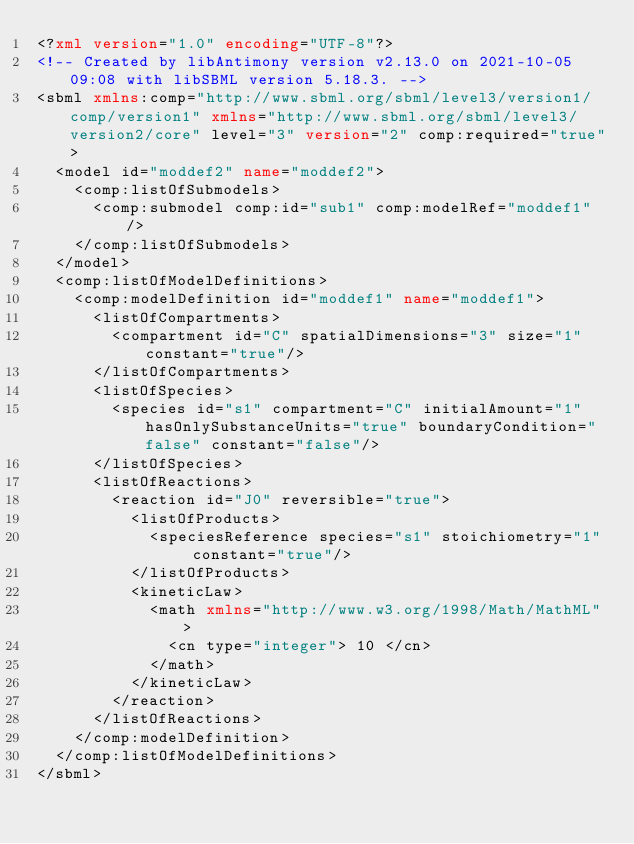<code> <loc_0><loc_0><loc_500><loc_500><_XML_><?xml version="1.0" encoding="UTF-8"?>
<!-- Created by libAntimony version v2.13.0 on 2021-10-05 09:08 with libSBML version 5.18.3. -->
<sbml xmlns:comp="http://www.sbml.org/sbml/level3/version1/comp/version1" xmlns="http://www.sbml.org/sbml/level3/version2/core" level="3" version="2" comp:required="true">
  <model id="moddef2" name="moddef2">
    <comp:listOfSubmodels>
      <comp:submodel comp:id="sub1" comp:modelRef="moddef1"/>
    </comp:listOfSubmodels>
  </model>
  <comp:listOfModelDefinitions>
    <comp:modelDefinition id="moddef1" name="moddef1">
      <listOfCompartments>
        <compartment id="C" spatialDimensions="3" size="1" constant="true"/>
      </listOfCompartments>
      <listOfSpecies>
        <species id="s1" compartment="C" initialAmount="1" hasOnlySubstanceUnits="true" boundaryCondition="false" constant="false"/>
      </listOfSpecies>
      <listOfReactions>
        <reaction id="J0" reversible="true">
          <listOfProducts>
            <speciesReference species="s1" stoichiometry="1" constant="true"/>
          </listOfProducts>
          <kineticLaw>
            <math xmlns="http://www.w3.org/1998/Math/MathML">
              <cn type="integer"> 10 </cn>
            </math>
          </kineticLaw>
        </reaction>
      </listOfReactions>
    </comp:modelDefinition>
  </comp:listOfModelDefinitions>
</sbml>
</code> 